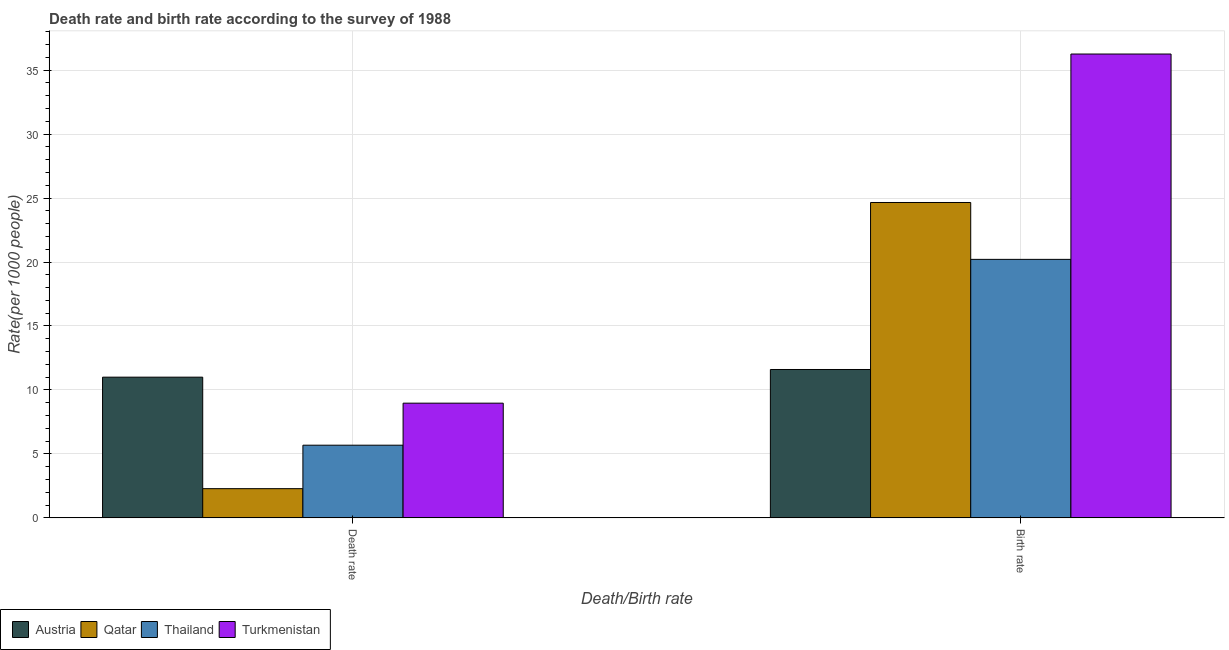How many different coloured bars are there?
Keep it short and to the point. 4. How many groups of bars are there?
Provide a succinct answer. 2. How many bars are there on the 2nd tick from the left?
Keep it short and to the point. 4. How many bars are there on the 2nd tick from the right?
Make the answer very short. 4. What is the label of the 1st group of bars from the left?
Your answer should be compact. Death rate. What is the death rate in Thailand?
Your answer should be very brief. 5.68. Across all countries, what is the maximum birth rate?
Make the answer very short. 36.26. Across all countries, what is the minimum death rate?
Keep it short and to the point. 2.29. What is the total birth rate in the graph?
Your answer should be compact. 92.72. What is the difference between the death rate in Thailand and that in Qatar?
Your answer should be very brief. 3.4. What is the difference between the birth rate in Turkmenistan and the death rate in Qatar?
Offer a terse response. 33.97. What is the average birth rate per country?
Ensure brevity in your answer.  23.18. What is the difference between the birth rate and death rate in Turkmenistan?
Give a very brief answer. 27.29. What is the ratio of the birth rate in Austria to that in Thailand?
Your answer should be compact. 0.57. Is the death rate in Turkmenistan less than that in Thailand?
Give a very brief answer. No. In how many countries, is the birth rate greater than the average birth rate taken over all countries?
Your answer should be very brief. 2. What does the 3rd bar from the left in Death rate represents?
Ensure brevity in your answer.  Thailand. What does the 1st bar from the right in Birth rate represents?
Ensure brevity in your answer.  Turkmenistan. Are all the bars in the graph horizontal?
Provide a short and direct response. No. Where does the legend appear in the graph?
Keep it short and to the point. Bottom left. How are the legend labels stacked?
Keep it short and to the point. Horizontal. What is the title of the graph?
Provide a short and direct response. Death rate and birth rate according to the survey of 1988. What is the label or title of the X-axis?
Provide a short and direct response. Death/Birth rate. What is the label or title of the Y-axis?
Give a very brief answer. Rate(per 1000 people). What is the Rate(per 1000 people) in Austria in Death rate?
Make the answer very short. 11. What is the Rate(per 1000 people) in Qatar in Death rate?
Your answer should be compact. 2.29. What is the Rate(per 1000 people) of Thailand in Death rate?
Your answer should be compact. 5.68. What is the Rate(per 1000 people) in Turkmenistan in Death rate?
Ensure brevity in your answer.  8.97. What is the Rate(per 1000 people) of Qatar in Birth rate?
Give a very brief answer. 24.65. What is the Rate(per 1000 people) in Thailand in Birth rate?
Make the answer very short. 20.21. What is the Rate(per 1000 people) in Turkmenistan in Birth rate?
Offer a very short reply. 36.26. Across all Death/Birth rate, what is the maximum Rate(per 1000 people) of Qatar?
Your response must be concise. 24.65. Across all Death/Birth rate, what is the maximum Rate(per 1000 people) of Thailand?
Keep it short and to the point. 20.21. Across all Death/Birth rate, what is the maximum Rate(per 1000 people) of Turkmenistan?
Your answer should be very brief. 36.26. Across all Death/Birth rate, what is the minimum Rate(per 1000 people) in Qatar?
Keep it short and to the point. 2.29. Across all Death/Birth rate, what is the minimum Rate(per 1000 people) of Thailand?
Give a very brief answer. 5.68. Across all Death/Birth rate, what is the minimum Rate(per 1000 people) of Turkmenistan?
Give a very brief answer. 8.97. What is the total Rate(per 1000 people) of Austria in the graph?
Offer a very short reply. 22.6. What is the total Rate(per 1000 people) in Qatar in the graph?
Make the answer very short. 26.94. What is the total Rate(per 1000 people) of Thailand in the graph?
Ensure brevity in your answer.  25.89. What is the total Rate(per 1000 people) in Turkmenistan in the graph?
Make the answer very short. 45.23. What is the difference between the Rate(per 1000 people) of Qatar in Death rate and that in Birth rate?
Make the answer very short. -22.37. What is the difference between the Rate(per 1000 people) of Thailand in Death rate and that in Birth rate?
Provide a short and direct response. -14.53. What is the difference between the Rate(per 1000 people) of Turkmenistan in Death rate and that in Birth rate?
Your response must be concise. -27.29. What is the difference between the Rate(per 1000 people) in Austria in Death rate and the Rate(per 1000 people) in Qatar in Birth rate?
Make the answer very short. -13.65. What is the difference between the Rate(per 1000 people) of Austria in Death rate and the Rate(per 1000 people) of Thailand in Birth rate?
Make the answer very short. -9.21. What is the difference between the Rate(per 1000 people) in Austria in Death rate and the Rate(per 1000 people) in Turkmenistan in Birth rate?
Ensure brevity in your answer.  -25.26. What is the difference between the Rate(per 1000 people) of Qatar in Death rate and the Rate(per 1000 people) of Thailand in Birth rate?
Ensure brevity in your answer.  -17.92. What is the difference between the Rate(per 1000 people) in Qatar in Death rate and the Rate(per 1000 people) in Turkmenistan in Birth rate?
Keep it short and to the point. -33.97. What is the difference between the Rate(per 1000 people) in Thailand in Death rate and the Rate(per 1000 people) in Turkmenistan in Birth rate?
Offer a very short reply. -30.57. What is the average Rate(per 1000 people) in Qatar per Death/Birth rate?
Offer a terse response. 13.47. What is the average Rate(per 1000 people) of Thailand per Death/Birth rate?
Offer a very short reply. 12.95. What is the average Rate(per 1000 people) of Turkmenistan per Death/Birth rate?
Provide a succinct answer. 22.61. What is the difference between the Rate(per 1000 people) in Austria and Rate(per 1000 people) in Qatar in Death rate?
Ensure brevity in your answer.  8.71. What is the difference between the Rate(per 1000 people) of Austria and Rate(per 1000 people) of Thailand in Death rate?
Keep it short and to the point. 5.32. What is the difference between the Rate(per 1000 people) in Austria and Rate(per 1000 people) in Turkmenistan in Death rate?
Give a very brief answer. 2.03. What is the difference between the Rate(per 1000 people) in Qatar and Rate(per 1000 people) in Thailand in Death rate?
Your answer should be compact. -3.4. What is the difference between the Rate(per 1000 people) of Qatar and Rate(per 1000 people) of Turkmenistan in Death rate?
Give a very brief answer. -6.68. What is the difference between the Rate(per 1000 people) in Thailand and Rate(per 1000 people) in Turkmenistan in Death rate?
Keep it short and to the point. -3.29. What is the difference between the Rate(per 1000 people) in Austria and Rate(per 1000 people) in Qatar in Birth rate?
Keep it short and to the point. -13.05. What is the difference between the Rate(per 1000 people) of Austria and Rate(per 1000 people) of Thailand in Birth rate?
Ensure brevity in your answer.  -8.61. What is the difference between the Rate(per 1000 people) of Austria and Rate(per 1000 people) of Turkmenistan in Birth rate?
Give a very brief answer. -24.66. What is the difference between the Rate(per 1000 people) of Qatar and Rate(per 1000 people) of Thailand in Birth rate?
Offer a very short reply. 4.45. What is the difference between the Rate(per 1000 people) in Qatar and Rate(per 1000 people) in Turkmenistan in Birth rate?
Provide a succinct answer. -11.61. What is the difference between the Rate(per 1000 people) of Thailand and Rate(per 1000 people) of Turkmenistan in Birth rate?
Keep it short and to the point. -16.05. What is the ratio of the Rate(per 1000 people) of Austria in Death rate to that in Birth rate?
Offer a terse response. 0.95. What is the ratio of the Rate(per 1000 people) of Qatar in Death rate to that in Birth rate?
Your answer should be compact. 0.09. What is the ratio of the Rate(per 1000 people) of Thailand in Death rate to that in Birth rate?
Your response must be concise. 0.28. What is the ratio of the Rate(per 1000 people) in Turkmenistan in Death rate to that in Birth rate?
Keep it short and to the point. 0.25. What is the difference between the highest and the second highest Rate(per 1000 people) in Austria?
Ensure brevity in your answer.  0.6. What is the difference between the highest and the second highest Rate(per 1000 people) of Qatar?
Offer a terse response. 22.37. What is the difference between the highest and the second highest Rate(per 1000 people) of Thailand?
Provide a short and direct response. 14.53. What is the difference between the highest and the second highest Rate(per 1000 people) of Turkmenistan?
Ensure brevity in your answer.  27.29. What is the difference between the highest and the lowest Rate(per 1000 people) in Austria?
Your response must be concise. 0.6. What is the difference between the highest and the lowest Rate(per 1000 people) of Qatar?
Provide a succinct answer. 22.37. What is the difference between the highest and the lowest Rate(per 1000 people) in Thailand?
Make the answer very short. 14.53. What is the difference between the highest and the lowest Rate(per 1000 people) in Turkmenistan?
Give a very brief answer. 27.29. 